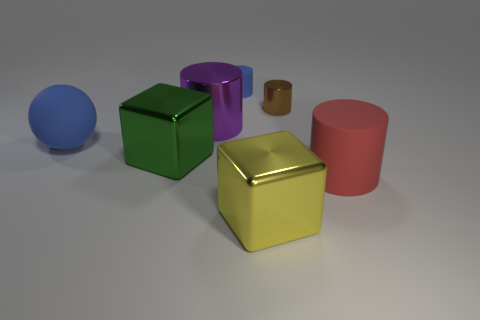How many other things are the same color as the small rubber thing?
Provide a short and direct response. 1. How many brown things are either big matte cylinders or tiny rubber objects?
Make the answer very short. 0. There is a purple metallic object; does it have the same shape as the large rubber object that is in front of the big blue rubber sphere?
Ensure brevity in your answer.  Yes. What is the shape of the red rubber thing?
Keep it short and to the point. Cylinder. What material is the yellow object that is the same size as the green shiny thing?
Ensure brevity in your answer.  Metal. Are there any other things that have the same size as the red rubber cylinder?
Keep it short and to the point. Yes. What number of things are either large red rubber spheres or rubber cylinders that are behind the green metallic cube?
Provide a succinct answer. 1. The brown cylinder that is made of the same material as the large yellow block is what size?
Offer a terse response. Small. The tiny object that is left of the big shiny cube right of the blue cylinder is what shape?
Your answer should be compact. Cylinder. There is a metallic object that is both to the left of the small brown shiny object and behind the large green thing; how big is it?
Give a very brief answer. Large. 